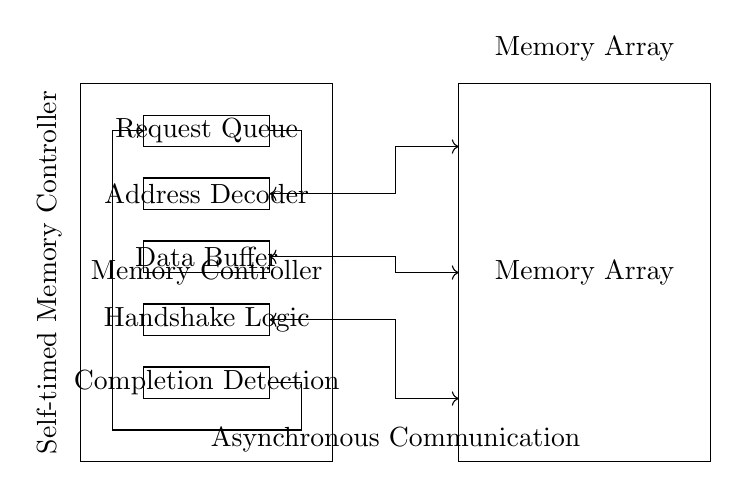What is the main function of the Memory Controller? The Memory Controller manages data access to the Memory Array and is responsible for coordinating requests, addresses, and data flow.
Answer: Manages data access What are the components inside the Memory Controller? The components include Request Queue, Address Decoder, Data Buffer, Handshake Logic, and Completion Detection, which together facilitate the efficient operation of the memory controller.
Answer: Request Queue, Address Decoder, Data Buffer, Handshake Logic, Completion Detection What is the purpose of the Address Decoder? The Address Decoder translates memory addresses from the control signals to access specific locations in the Memory Array, making it essential for locating the desired data.
Answer: Access specific locations How does the Handshake Logic function in this circuit? The Handshake Logic controls the communication timing between the Memory Controller and the Memory Array, ensuring that the system operates asynchronously and that data transfer occurs efficiently without collision.
Answer: Controls communication timing What type of communication is utilized by this circuit? The circuit uses asynchronous communication, allowing flexibility in timing between signals, which helps improve data access efficiency.
Answer: Asynchronous communication How does the Completion Detection improve data access efficiency? Completion Detection recognizes when data operations are complete, allowing the system to manage subsequent requests without unnecessary delays, thus enhancing overall performance.
Answer: Recognizes completion efficiently 